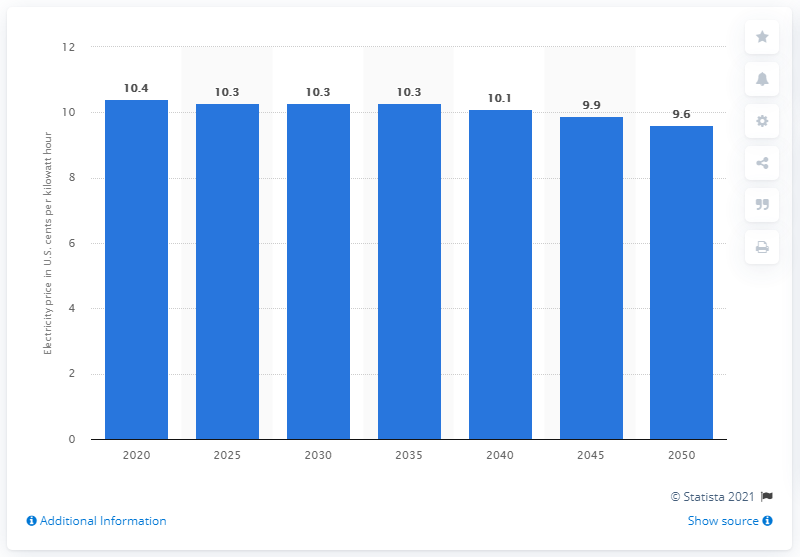Point out several critical features in this image. The projected decrease in the average end-use price of electricity by 2050 is expected to be 9.6%. In 2020, the average end-use price of electricity in the United States was 10.4 cents per kilowatt-hour. 